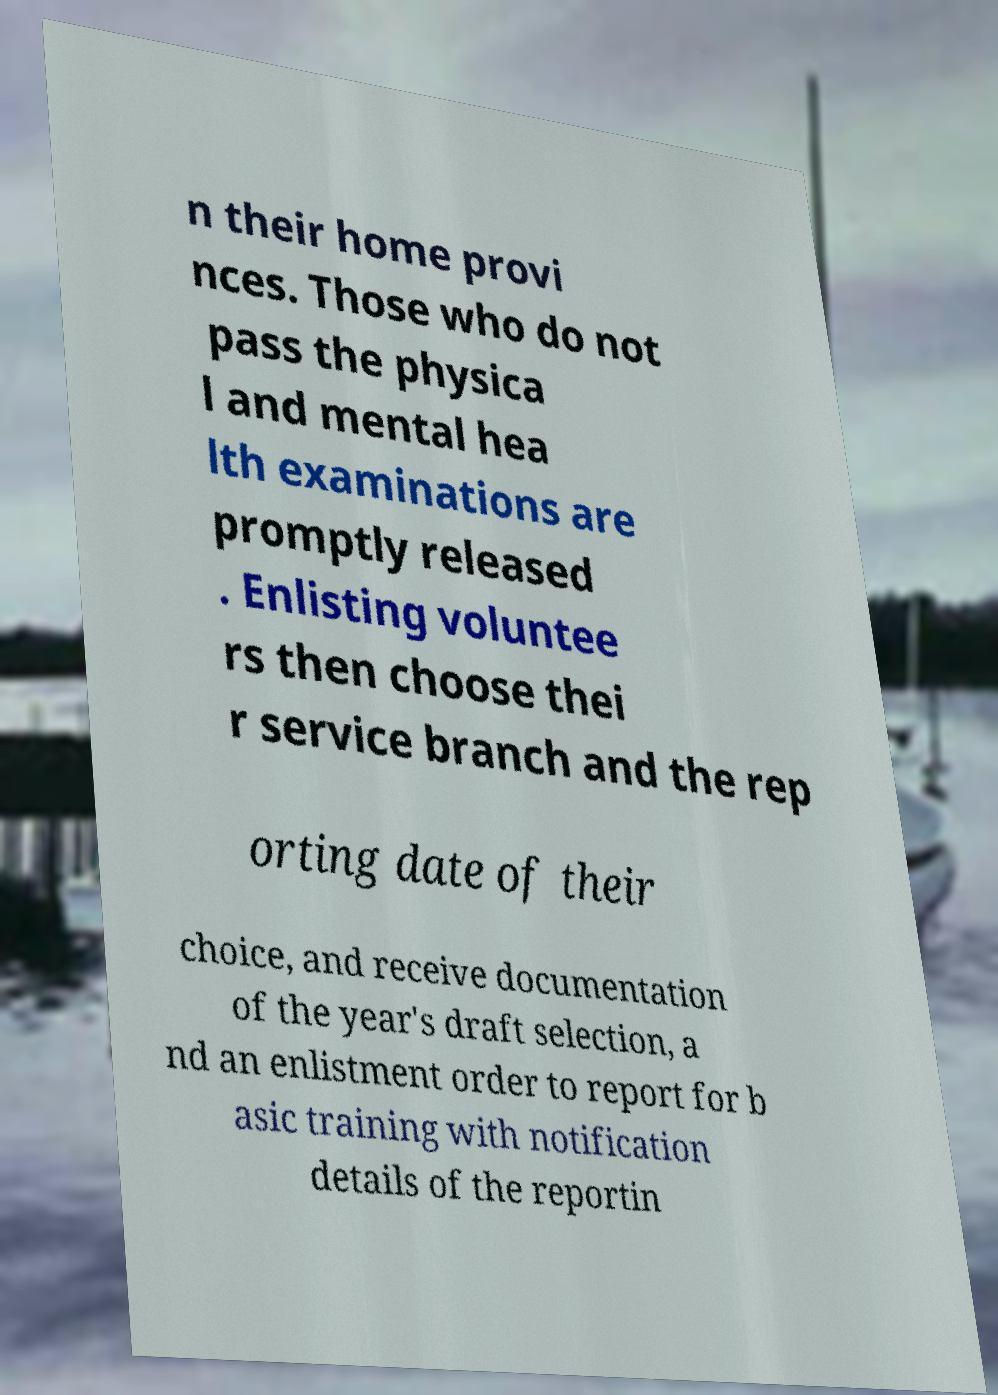I need the written content from this picture converted into text. Can you do that? n their home provi nces. Those who do not pass the physica l and mental hea lth examinations are promptly released . Enlisting voluntee rs then choose thei r service branch and the rep orting date of their choice, and receive documentation of the year's draft selection, a nd an enlistment order to report for b asic training with notification details of the reportin 